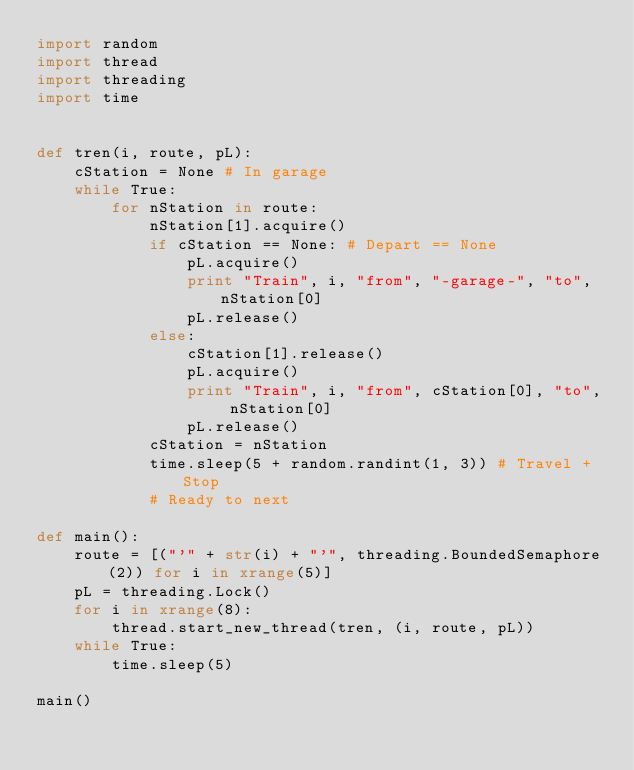<code> <loc_0><loc_0><loc_500><loc_500><_Python_>import random
import thread
import threading
import time


def tren(i, route, pL):
    cStation = None # In garage
    while True:
        for nStation in route:
            nStation[1].acquire()
            if cStation == None: # Depart == None
                pL.acquire()
                print "Train", i, "from", "-garage-", "to", nStation[0]
                pL.release()
            else:
                cStation[1].release()
                pL.acquire()
                print "Train", i, "from", cStation[0], "to", nStation[0]
                pL.release()
            cStation = nStation
            time.sleep(5 + random.randint(1, 3)) # Travel + Stop
            # Ready to next

def main():
    route = [("'" + str(i) + "'", threading.BoundedSemaphore(2)) for i in xrange(5)]
    pL = threading.Lock()
    for i in xrange(8):
        thread.start_new_thread(tren, (i, route, pL))
    while True:
        time.sleep(5)

main()
</code> 